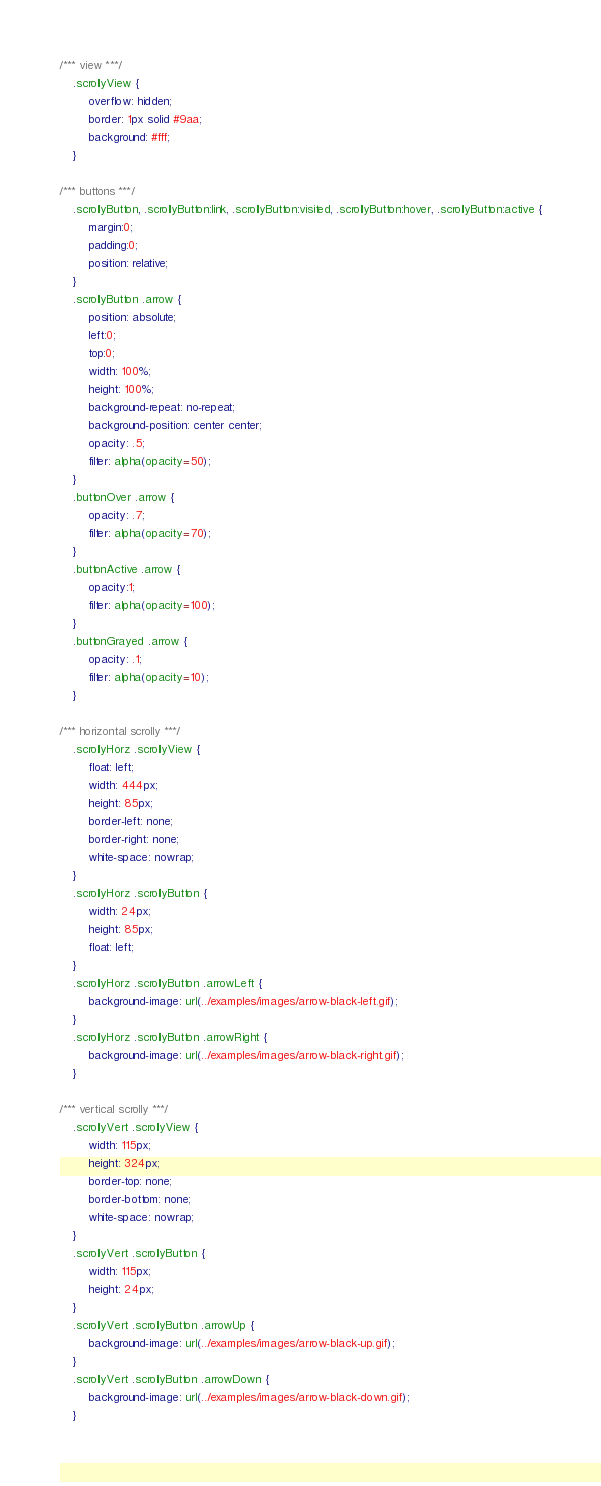Convert code to text. <code><loc_0><loc_0><loc_500><loc_500><_CSS_>/*** view ***/
	.scrollyView {
		overflow: hidden;
		border: 1px solid #9aa;
		background: #fff;
	}

/*** buttons ***/
	.scrollyButton, .scrollyButton:link, .scrollyButton:visited, .scrollyButton:hover, .scrollyButton:active {
		margin:0;
		padding:0;
		position: relative;
	}
	.scrollyButton .arrow {
		position: absolute;
		left:0;
		top:0;
		width: 100%;
		height: 100%;
		background-repeat: no-repeat;
		background-position: center center;
		opacity: .5;
		filter: alpha(opacity=50);
	}
	.buttonOver .arrow {
		opacity: .7;
		filter: alpha(opacity=70);
	}
	.buttonActive .arrow {
		opacity:1;
		filter: alpha(opacity=100);
	}
	.buttonGrayed .arrow {
		opacity: .1;
		filter: alpha(opacity=10);
	}

/*** horizontal scrolly ***/
	.scrollyHorz .scrollyView {
		float: left;
		width: 444px;
		height: 85px;
		border-left: none;
		border-right: none;
		white-space: nowrap;
	}
	.scrollyHorz .scrollyButton {
		width: 24px;
		height: 85px;
		float: left;
	}
	.scrollyHorz .scrollyButton .arrowLeft {
		background-image: url(../examples/images/arrow-black-left.gif);
	}
	.scrollyHorz .scrollyButton .arrowRight {
		background-image: url(../examples/images/arrow-black-right.gif);
	}

/*** vertical scrolly ***/
	.scrollyVert .scrollyView {
		width: 115px;
		height: 324px;
		border-top: none;
		border-bottom: none;
		white-space: nowrap;
	}
	.scrollyVert .scrollyButton {
		width: 115px;
		height: 24px;
	}
	.scrollyVert .scrollyButton .arrowUp {
		background-image: url(../examples/images/arrow-black-up.gif);
	}
	.scrollyVert .scrollyButton .arrowDown {
		background-image: url(../examples/images/arrow-black-down.gif);
	}

</code> 